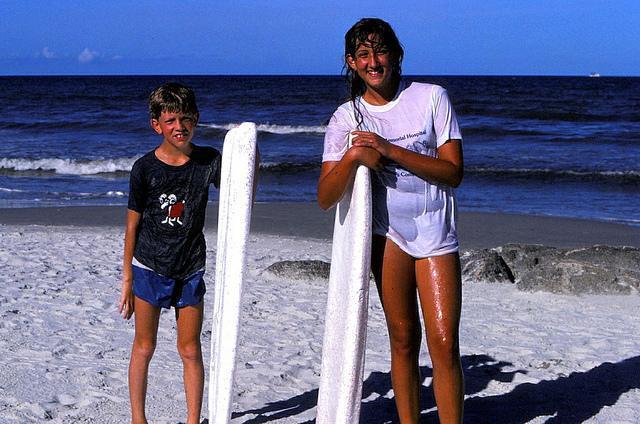How many people are there?
Give a very brief answer. 2. How many surfboards are there?
Give a very brief answer. 2. 